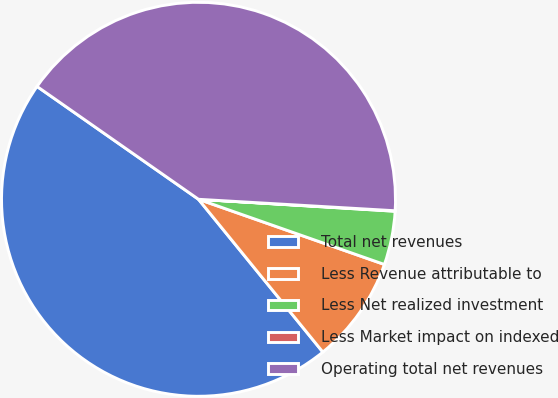<chart> <loc_0><loc_0><loc_500><loc_500><pie_chart><fcel>Total net revenues<fcel>Less Revenue attributable to<fcel>Less Net realized investment<fcel>Less Market impact on indexed<fcel>Operating total net revenues<nl><fcel>45.58%<fcel>8.76%<fcel>4.4%<fcel>0.04%<fcel>41.22%<nl></chart> 